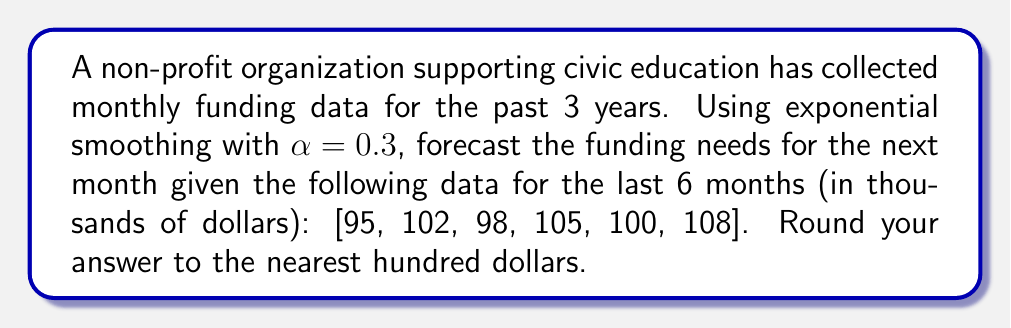Show me your answer to this math problem. To forecast future funding needs using exponential smoothing, we'll follow these steps:

1) The exponential smoothing formula is:
   $$F_{t+1} = \alpha Y_t + (1-\alpha)F_t$$
   where $F_{t+1}$ is the forecast for the next period, $Y_t$ is the actual value at time $t$, and $F_t$ is the forecast for the current period.

2) We're given $\alpha = 0.3$. We need to start with the first available forecast. Let's use the first actual value as our initial forecast:
   $$F_1 = 95$$

3) Now, let's calculate each forecast:

   For $t = 2$:
   $$F_2 = 0.3(95) + 0.7(95) = 95$$

   For $t = 3$:
   $$F_3 = 0.3(102) + 0.7(95) = 97.1$$

   For $t = 4$:
   $$F_4 = 0.3(98) + 0.7(97.1) = 97.37$$

   For $t = 5$:
   $$F_5 = 0.3(105) + 0.7(97.37) = 99.759$$

   For $t = 6$:
   $$F_6 = 0.3(100) + 0.7(99.759) = 99.8313$$

4) Finally, for $t = 7$ (our forecast):
   $$F_7 = 0.3(108) + 0.7(99.8313) = 102.48191$$

5) Rounding to the nearest hundred dollars:
   $$102,48191 \approx 102,500$$
Answer: $102,500 